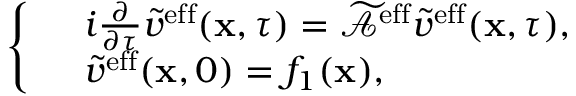<formula> <loc_0><loc_0><loc_500><loc_500>\left \{ \begin{array} { r l } & { i \frac { \partial } { \partial \tau } \tilde { v } ^ { e f f } ( x , \tau ) = \widetilde { \mathcal { A } } ^ { e f f } \tilde { v } ^ { e f f } ( x , \tau ) , } \\ & { \tilde { v } ^ { e f f } ( x , 0 ) = f _ { 1 } ( x ) , } \end{array}</formula> 